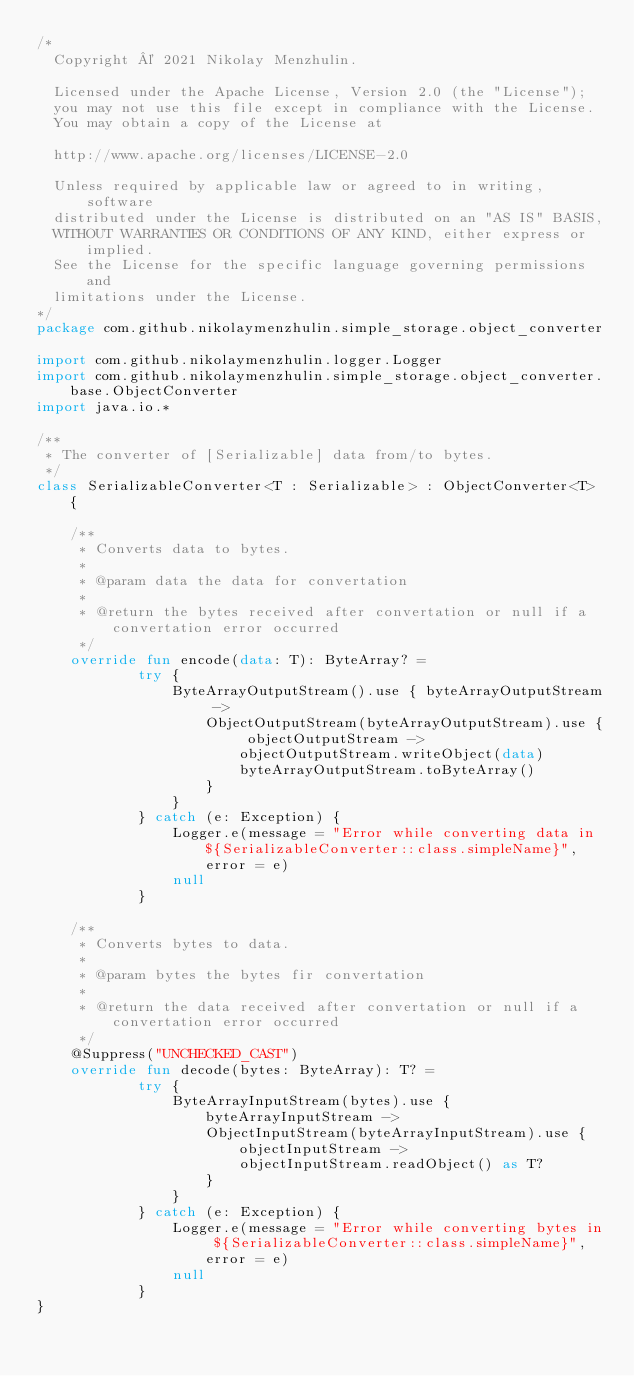<code> <loc_0><loc_0><loc_500><loc_500><_Kotlin_>/*
  Copyright © 2021 Nikolay Menzhulin.

  Licensed under the Apache License, Version 2.0 (the "License");
  you may not use this file except in compliance with the License.
  You may obtain a copy of the License at

  http://www.apache.org/licenses/LICENSE-2.0

  Unless required by applicable law or agreed to in writing, software
  distributed under the License is distributed on an "AS IS" BASIS,
  WITHOUT WARRANTIES OR CONDITIONS OF ANY KIND, either express or implied.
  See the License for the specific language governing permissions and
  limitations under the License.
*/
package com.github.nikolaymenzhulin.simple_storage.object_converter

import com.github.nikolaymenzhulin.logger.Logger
import com.github.nikolaymenzhulin.simple_storage.object_converter.base.ObjectConverter
import java.io.*

/**
 * The converter of [Serializable] data from/to bytes.
 */
class SerializableConverter<T : Serializable> : ObjectConverter<T> {

    /**
     * Converts data to bytes.
     *
     * @param data the data for convertation
     *
     * @return the bytes received after convertation or null if a convertation error occurred
     */
    override fun encode(data: T): ByteArray? =
            try {
                ByteArrayOutputStream().use { byteArrayOutputStream ->
                    ObjectOutputStream(byteArrayOutputStream).use { objectOutputStream ->
                        objectOutputStream.writeObject(data)
                        byteArrayOutputStream.toByteArray()
                    }
                }
            } catch (e: Exception) {
                Logger.e(message = "Error while converting data in ${SerializableConverter::class.simpleName}", error = e)
                null
            }

    /**
     * Converts bytes to data.
     *
     * @param bytes the bytes fir convertation
     *
     * @return the data received after convertation or null if a convertation error occurred
     */
    @Suppress("UNCHECKED_CAST")
    override fun decode(bytes: ByteArray): T? =
            try {
                ByteArrayInputStream(bytes).use { byteArrayInputStream ->
                    ObjectInputStream(byteArrayInputStream).use { objectInputStream ->
                        objectInputStream.readObject() as T?
                    }
                }
            } catch (e: Exception) {
                Logger.e(message = "Error while converting bytes in ${SerializableConverter::class.simpleName}", error = e)
                null
            }
}</code> 